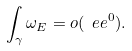Convert formula to latex. <formula><loc_0><loc_0><loc_500><loc_500>\int _ { \gamma } { \omega _ { E } } = o ( \ e e ^ { 0 } ) .</formula> 